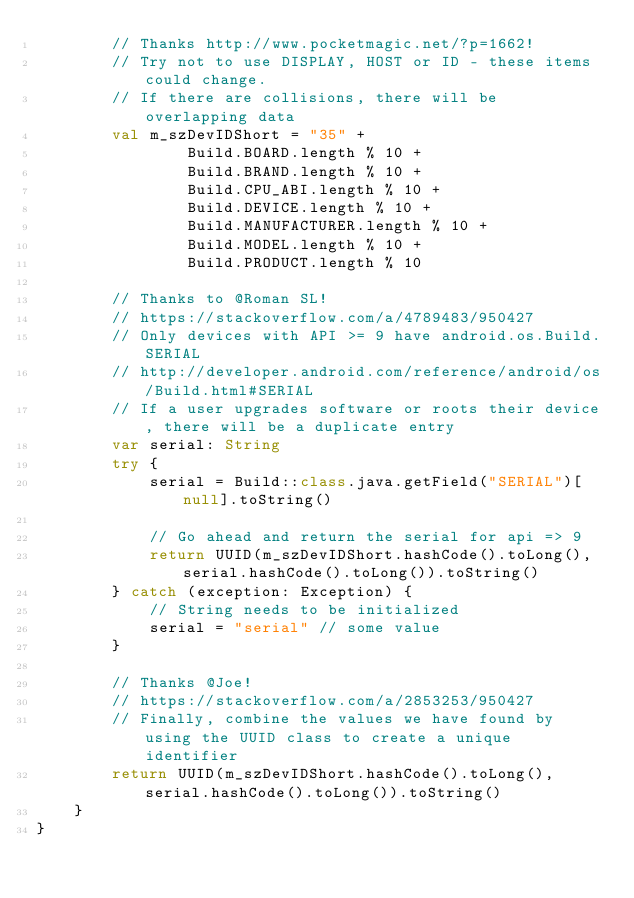Convert code to text. <code><loc_0><loc_0><loc_500><loc_500><_Kotlin_>        // Thanks http://www.pocketmagic.net/?p=1662!
        // Try not to use DISPLAY, HOST or ID - these items could change.
        // If there are collisions, there will be overlapping data
        val m_szDevIDShort = "35" +
                Build.BOARD.length % 10 +
                Build.BRAND.length % 10 +
                Build.CPU_ABI.length % 10 +
                Build.DEVICE.length % 10 +
                Build.MANUFACTURER.length % 10 +
                Build.MODEL.length % 10 +
                Build.PRODUCT.length % 10

        // Thanks to @Roman SL!
        // https://stackoverflow.com/a/4789483/950427
        // Only devices with API >= 9 have android.os.Build.SERIAL
        // http://developer.android.com/reference/android/os/Build.html#SERIAL
        // If a user upgrades software or roots their device, there will be a duplicate entry
        var serial: String
        try {
            serial = Build::class.java.getField("SERIAL")[null].toString()

            // Go ahead and return the serial for api => 9
            return UUID(m_szDevIDShort.hashCode().toLong(), serial.hashCode().toLong()).toString()
        } catch (exception: Exception) {
            // String needs to be initialized
            serial = "serial" // some value
        }

        // Thanks @Joe!
        // https://stackoverflow.com/a/2853253/950427
        // Finally, combine the values we have found by using the UUID class to create a unique identifier
        return UUID(m_szDevIDShort.hashCode().toLong(), serial.hashCode().toLong()).toString()
    }
}</code> 